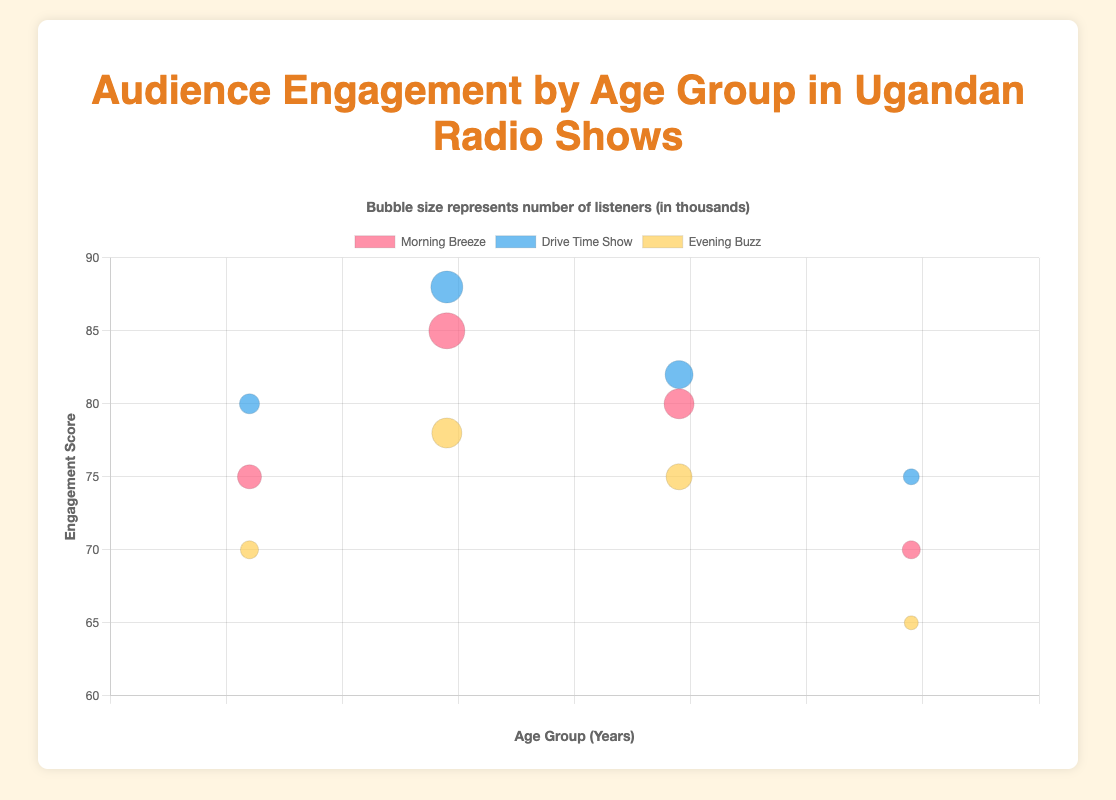What is the title of the chart? The title is displayed at the top of the chart in a larger font size.
Answer: Audience Engagement by Age Group in Ugandan Radio Shows What does the size of each bubble represent in the chart? The title within the plugins part of the figure states that the bubble size represents the number of listeners (in thousands).
Answer: Number of listeners (in thousands) Which age group has the highest engagement score for "Drive Time Show"? By looking at the y-axis for "Drive Time Show", the highest point is at 88 for the 25-34 age group.
Answer: 25-34 How many data points are plotted for "Morning Breeze"? The legend lists each radio show, and "Morning Breeze" has four bubbles plotted across different age groups.
Answer: 4 Compare the engagement score of the "Morning Breeze" for the 18-24 age group and the "Drive Time Show" for the 18-24 age group. Which one is higher? By examining the engagement scores on the y-axis, the "Morning Breeze" for 18-24 is at 75, and the "Drive Time Show" for 18-24 is at 80.
Answer: Drive Time Show Which radio show has the lowest engagement score and what is it? By scanning the y-axis for the lowest value across all shows, the "Evening Buzz" for the 45-54 age group is at 65.
Answer: Evening Buzz, 65 In the 35-44 age group, how many more listeners does the "Morning Breeze" have compared to the "Evening Buzz"? "Morning Breeze" has 15000 listeners, and "Evening Buzz" has 13000 listeners. The difference is 15000 - 13000.
Answer: 2000 Which age group has the smallest bubble for the "Evening Buzz"? By looking at the bubble sizes, the smallest bubble for "Evening Buzz" is for the 45-54 age group, representing 7000 listeners.
Answer: 45-54 Which radio show and age group combination has the highest number of listeners? By examining the largest bubble sizes, the 25-34 age group for "Morning Breeze" has 18000 listeners, the largest.
Answer: Morning Breeze, 25-34 What's the average engagement score for the "Drive Time Show"? Add the engagement scores for "Drive Time Show" (80 + 88 + 82 + 75) and divide by the number of points (4). The total is 325, and the average is 325/4.
Answer: 81.25 